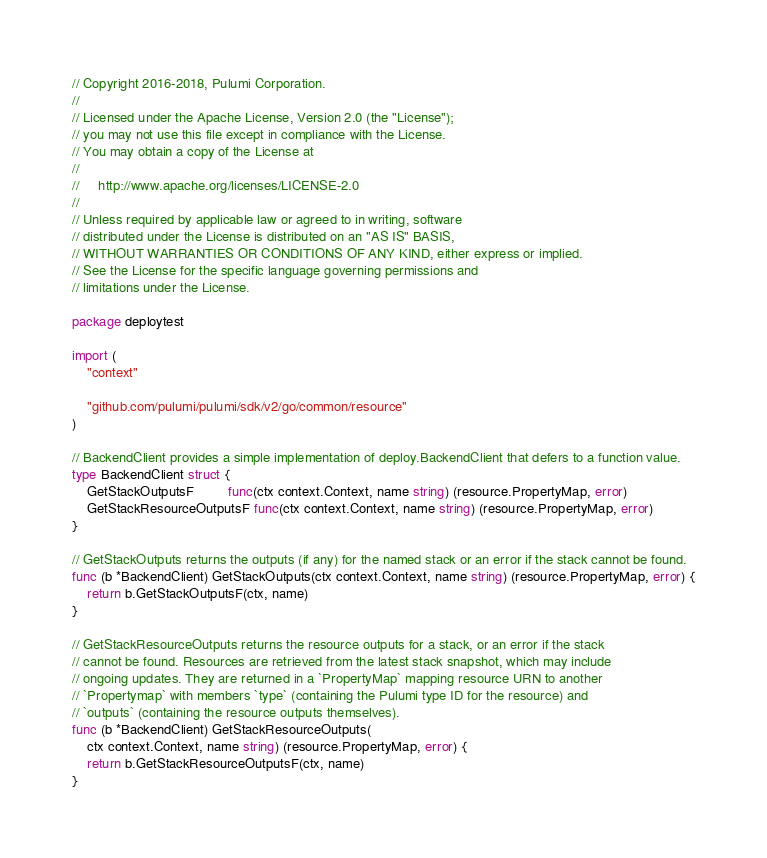<code> <loc_0><loc_0><loc_500><loc_500><_Go_>// Copyright 2016-2018, Pulumi Corporation.
//
// Licensed under the Apache License, Version 2.0 (the "License");
// you may not use this file except in compliance with the License.
// You may obtain a copy of the License at
//
//     http://www.apache.org/licenses/LICENSE-2.0
//
// Unless required by applicable law or agreed to in writing, software
// distributed under the License is distributed on an "AS IS" BASIS,
// WITHOUT WARRANTIES OR CONDITIONS OF ANY KIND, either express or implied.
// See the License for the specific language governing permissions and
// limitations under the License.

package deploytest

import (
	"context"

	"github.com/pulumi/pulumi/sdk/v2/go/common/resource"
)

// BackendClient provides a simple implementation of deploy.BackendClient that defers to a function value.
type BackendClient struct {
	GetStackOutputsF         func(ctx context.Context, name string) (resource.PropertyMap, error)
	GetStackResourceOutputsF func(ctx context.Context, name string) (resource.PropertyMap, error)
}

// GetStackOutputs returns the outputs (if any) for the named stack or an error if the stack cannot be found.
func (b *BackendClient) GetStackOutputs(ctx context.Context, name string) (resource.PropertyMap, error) {
	return b.GetStackOutputsF(ctx, name)
}

// GetStackResourceOutputs returns the resource outputs for a stack, or an error if the stack
// cannot be found. Resources are retrieved from the latest stack snapshot, which may include
// ongoing updates. They are returned in a `PropertyMap` mapping resource URN to another
// `Propertymap` with members `type` (containing the Pulumi type ID for the resource) and
// `outputs` (containing the resource outputs themselves).
func (b *BackendClient) GetStackResourceOutputs(
	ctx context.Context, name string) (resource.PropertyMap, error) {
	return b.GetStackResourceOutputsF(ctx, name)
}
</code> 